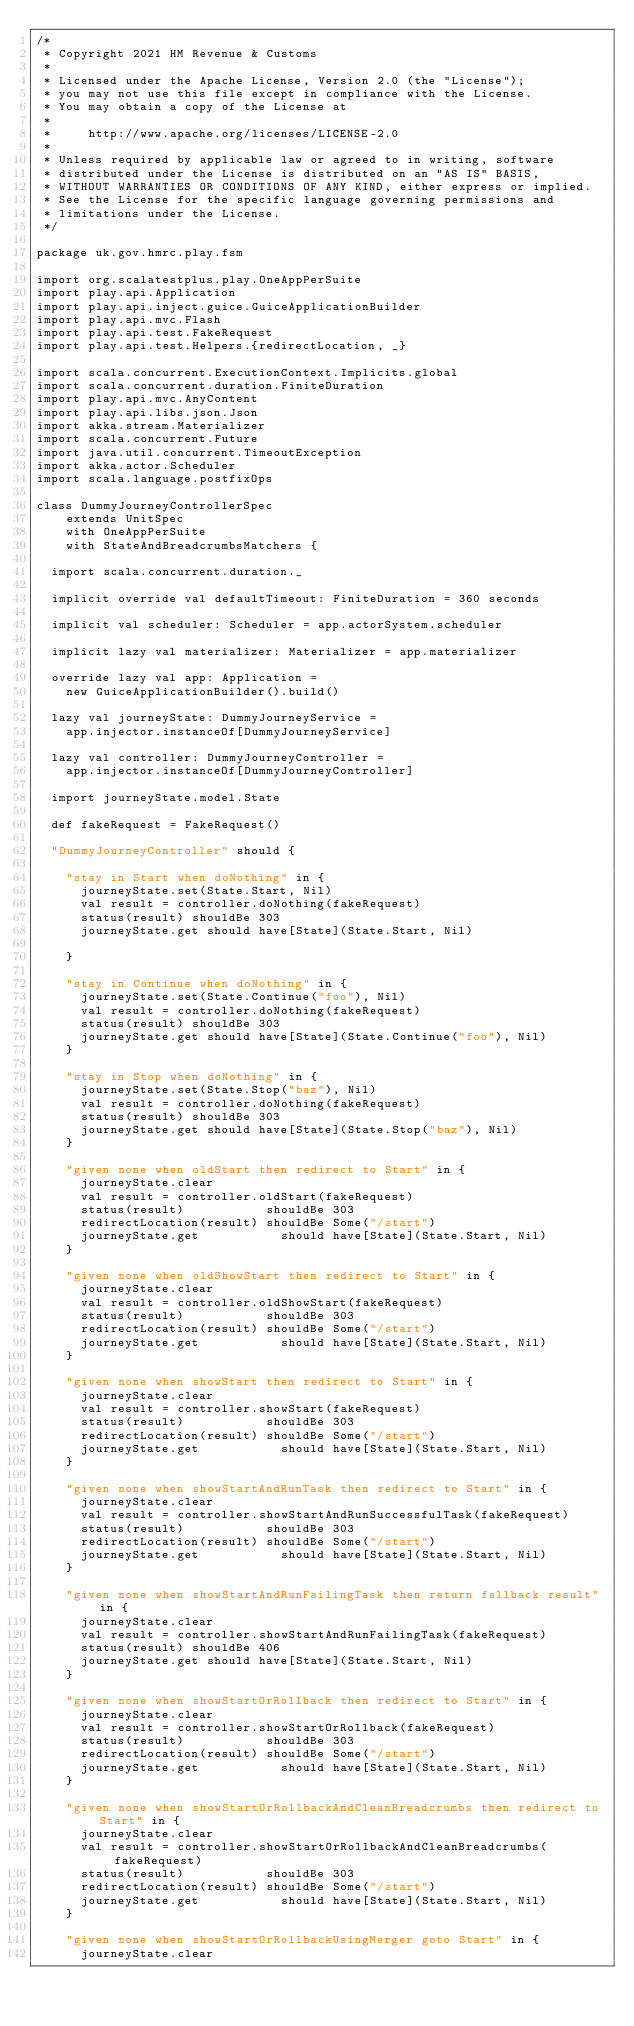<code> <loc_0><loc_0><loc_500><loc_500><_Scala_>/*
 * Copyright 2021 HM Revenue & Customs
 *
 * Licensed under the Apache License, Version 2.0 (the "License");
 * you may not use this file except in compliance with the License.
 * You may obtain a copy of the License at
 *
 *     http://www.apache.org/licenses/LICENSE-2.0
 *
 * Unless required by applicable law or agreed to in writing, software
 * distributed under the License is distributed on an "AS IS" BASIS,
 * WITHOUT WARRANTIES OR CONDITIONS OF ANY KIND, either express or implied.
 * See the License for the specific language governing permissions and
 * limitations under the License.
 */

package uk.gov.hmrc.play.fsm

import org.scalatestplus.play.OneAppPerSuite
import play.api.Application
import play.api.inject.guice.GuiceApplicationBuilder
import play.api.mvc.Flash
import play.api.test.FakeRequest
import play.api.test.Helpers.{redirectLocation, _}

import scala.concurrent.ExecutionContext.Implicits.global
import scala.concurrent.duration.FiniteDuration
import play.api.mvc.AnyContent
import play.api.libs.json.Json
import akka.stream.Materializer
import scala.concurrent.Future
import java.util.concurrent.TimeoutException
import akka.actor.Scheduler
import scala.language.postfixOps

class DummyJourneyControllerSpec
    extends UnitSpec
    with OneAppPerSuite
    with StateAndBreadcrumbsMatchers {

  import scala.concurrent.duration._

  implicit override val defaultTimeout: FiniteDuration = 360 seconds

  implicit val scheduler: Scheduler = app.actorSystem.scheduler

  implicit lazy val materializer: Materializer = app.materializer

  override lazy val app: Application =
    new GuiceApplicationBuilder().build()

  lazy val journeyState: DummyJourneyService =
    app.injector.instanceOf[DummyJourneyService]

  lazy val controller: DummyJourneyController =
    app.injector.instanceOf[DummyJourneyController]

  import journeyState.model.State

  def fakeRequest = FakeRequest()

  "DummyJourneyController" should {

    "stay in Start when doNothing" in {
      journeyState.set(State.Start, Nil)
      val result = controller.doNothing(fakeRequest)
      status(result) shouldBe 303
      journeyState.get should have[State](State.Start, Nil)

    }

    "stay in Continue when doNothing" in {
      journeyState.set(State.Continue("foo"), Nil)
      val result = controller.doNothing(fakeRequest)
      status(result) shouldBe 303
      journeyState.get should have[State](State.Continue("foo"), Nil)
    }

    "stay in Stop when doNothing" in {
      journeyState.set(State.Stop("baz"), Nil)
      val result = controller.doNothing(fakeRequest)
      status(result) shouldBe 303
      journeyState.get should have[State](State.Stop("baz"), Nil)
    }

    "given none when oldStart then redirect to Start" in {
      journeyState.clear
      val result = controller.oldStart(fakeRequest)
      status(result)           shouldBe 303
      redirectLocation(result) shouldBe Some("/start")
      journeyState.get           should have[State](State.Start, Nil)
    }

    "given none when oldShowStart then redirect to Start" in {
      journeyState.clear
      val result = controller.oldShowStart(fakeRequest)
      status(result)           shouldBe 303
      redirectLocation(result) shouldBe Some("/start")
      journeyState.get           should have[State](State.Start, Nil)
    }

    "given none when showStart then redirect to Start" in {
      journeyState.clear
      val result = controller.showStart(fakeRequest)
      status(result)           shouldBe 303
      redirectLocation(result) shouldBe Some("/start")
      journeyState.get           should have[State](State.Start, Nil)
    }

    "given none when showStartAndRunTask then redirect to Start" in {
      journeyState.clear
      val result = controller.showStartAndRunSuccessfulTask(fakeRequest)
      status(result)           shouldBe 303
      redirectLocation(result) shouldBe Some("/start")
      journeyState.get           should have[State](State.Start, Nil)
    }

    "given none when showStartAndRunFailingTask then return fallback result" in {
      journeyState.clear
      val result = controller.showStartAndRunFailingTask(fakeRequest)
      status(result) shouldBe 406
      journeyState.get should have[State](State.Start, Nil)
    }

    "given none when showStartOrRollback then redirect to Start" in {
      journeyState.clear
      val result = controller.showStartOrRollback(fakeRequest)
      status(result)           shouldBe 303
      redirectLocation(result) shouldBe Some("/start")
      journeyState.get           should have[State](State.Start, Nil)
    }

    "given none when showStartOrRollbackAndCleanBreadcrumbs then redirect to Start" in {
      journeyState.clear
      val result = controller.showStartOrRollbackAndCleanBreadcrumbs(fakeRequest)
      status(result)           shouldBe 303
      redirectLocation(result) shouldBe Some("/start")
      journeyState.get           should have[State](State.Start, Nil)
    }

    "given none when showStartOrRollbackUsingMerger goto Start" in {
      journeyState.clear</code> 